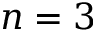Convert formula to latex. <formula><loc_0><loc_0><loc_500><loc_500>n = 3</formula> 